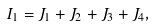<formula> <loc_0><loc_0><loc_500><loc_500>I _ { 1 } & = J _ { 1 } + J _ { 2 } + J _ { 3 } + J _ { 4 } ,</formula> 